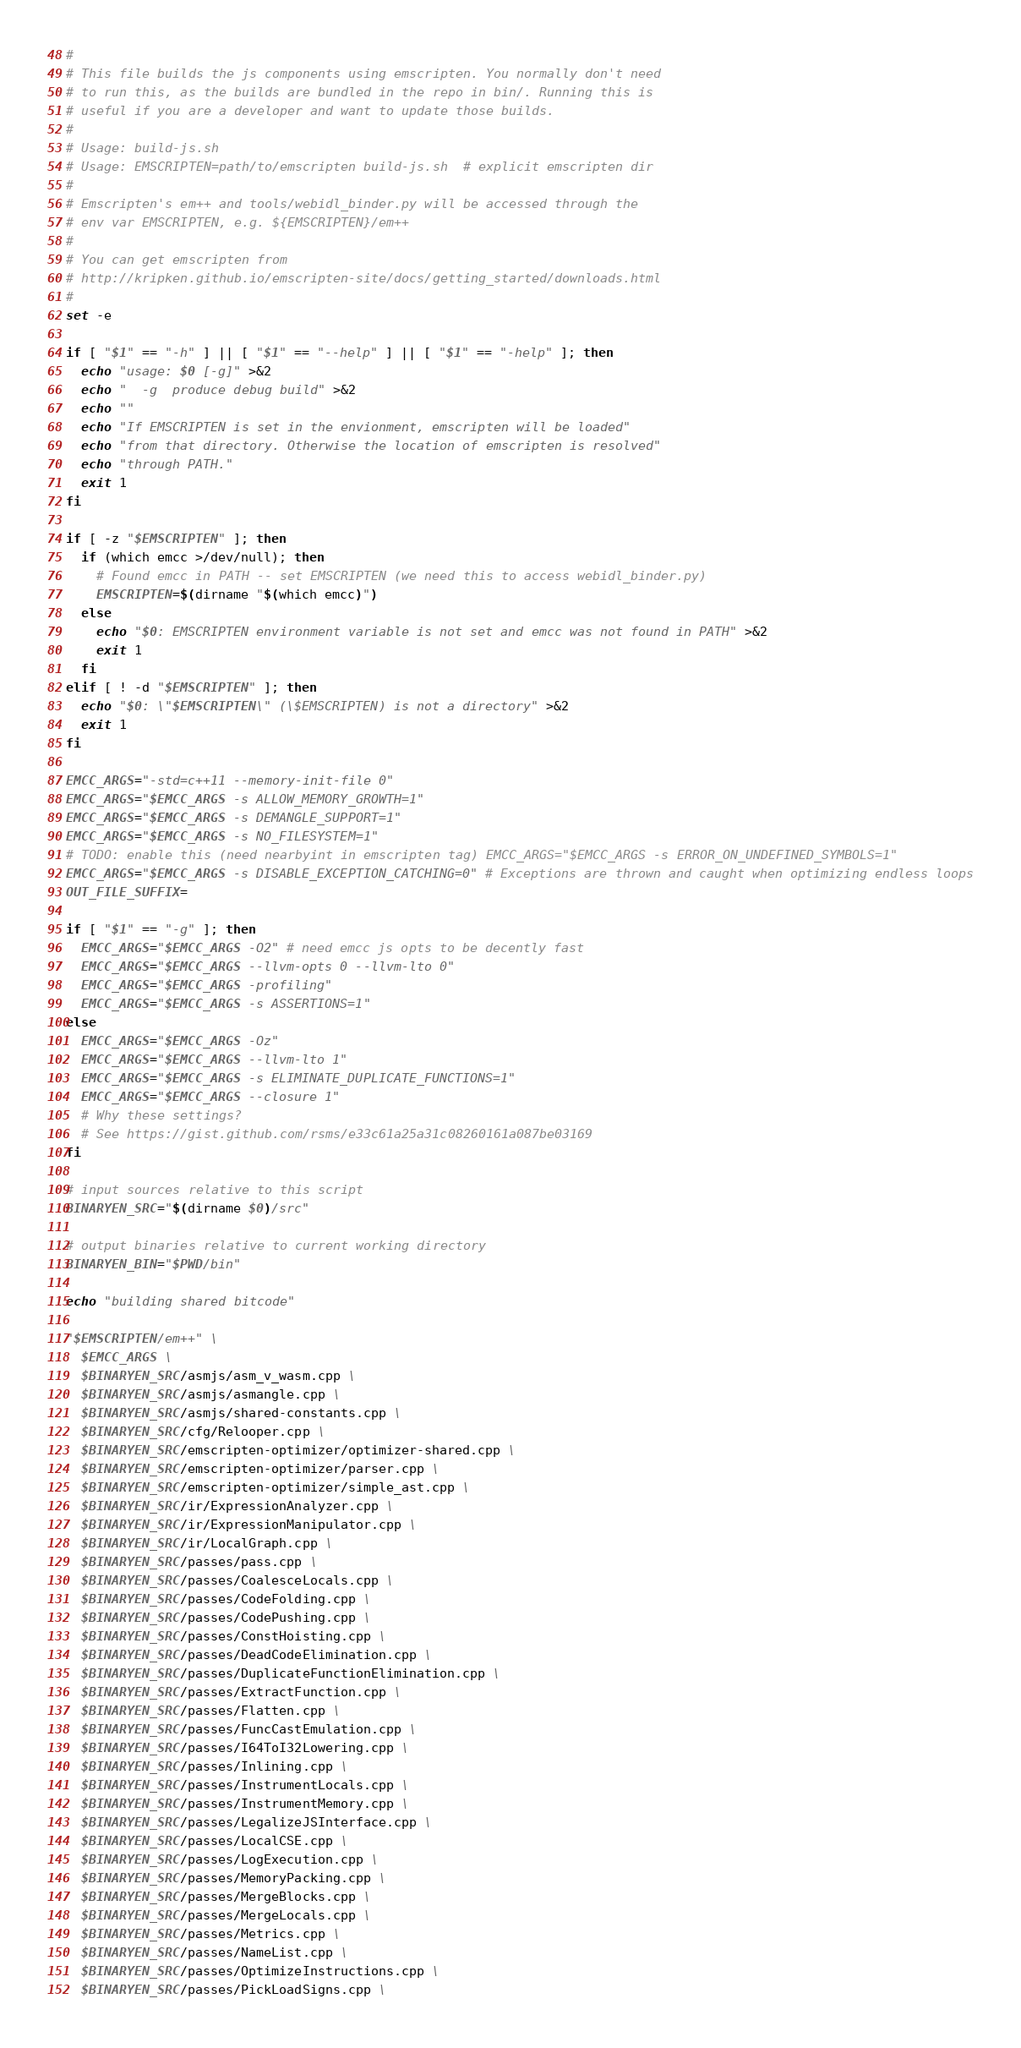<code> <loc_0><loc_0><loc_500><loc_500><_Bash_>#
# This file builds the js components using emscripten. You normally don't need
# to run this, as the builds are bundled in the repo in bin/. Running this is
# useful if you are a developer and want to update those builds.
#
# Usage: build-js.sh
# Usage: EMSCRIPTEN=path/to/emscripten build-js.sh  # explicit emscripten dir
#
# Emscripten's em++ and tools/webidl_binder.py will be accessed through the
# env var EMSCRIPTEN, e.g. ${EMSCRIPTEN}/em++
#
# You can get emscripten from
# http://kripken.github.io/emscripten-site/docs/getting_started/downloads.html
#
set -e

if [ "$1" == "-h" ] || [ "$1" == "--help" ] || [ "$1" == "-help" ]; then
  echo "usage: $0 [-g]" >&2
  echo "  -g  produce debug build" >&2
  echo ""
  echo "If EMSCRIPTEN is set in the envionment, emscripten will be loaded"
  echo "from that directory. Otherwise the location of emscripten is resolved"
  echo "through PATH."
  exit 1
fi

if [ -z "$EMSCRIPTEN" ]; then
  if (which emcc >/dev/null); then
    # Found emcc in PATH -- set EMSCRIPTEN (we need this to access webidl_binder.py)
    EMSCRIPTEN=$(dirname "$(which emcc)")
  else
    echo "$0: EMSCRIPTEN environment variable is not set and emcc was not found in PATH" >&2
    exit 1
  fi
elif [ ! -d "$EMSCRIPTEN" ]; then
  echo "$0: \"$EMSCRIPTEN\" (\$EMSCRIPTEN) is not a directory" >&2
  exit 1
fi

EMCC_ARGS="-std=c++11 --memory-init-file 0"
EMCC_ARGS="$EMCC_ARGS -s ALLOW_MEMORY_GROWTH=1"
EMCC_ARGS="$EMCC_ARGS -s DEMANGLE_SUPPORT=1"
EMCC_ARGS="$EMCC_ARGS -s NO_FILESYSTEM=1"
# TODO: enable this (need nearbyint in emscripten tag) EMCC_ARGS="$EMCC_ARGS -s ERROR_ON_UNDEFINED_SYMBOLS=1"
EMCC_ARGS="$EMCC_ARGS -s DISABLE_EXCEPTION_CATCHING=0" # Exceptions are thrown and caught when optimizing endless loops
OUT_FILE_SUFFIX=

if [ "$1" == "-g" ]; then
  EMCC_ARGS="$EMCC_ARGS -O2" # need emcc js opts to be decently fast
  EMCC_ARGS="$EMCC_ARGS --llvm-opts 0 --llvm-lto 0"
  EMCC_ARGS="$EMCC_ARGS -profiling"
  EMCC_ARGS="$EMCC_ARGS -s ASSERTIONS=1"
else
  EMCC_ARGS="$EMCC_ARGS -Oz"
  EMCC_ARGS="$EMCC_ARGS --llvm-lto 1"
  EMCC_ARGS="$EMCC_ARGS -s ELIMINATE_DUPLICATE_FUNCTIONS=1"
  EMCC_ARGS="$EMCC_ARGS --closure 1"
  # Why these settings?
  # See https://gist.github.com/rsms/e33c61a25a31c08260161a087be03169
fi

# input sources relative to this script
BINARYEN_SRC="$(dirname $0)/src"

# output binaries relative to current working directory
BINARYEN_BIN="$PWD/bin"

echo "building shared bitcode"

"$EMSCRIPTEN/em++" \
  $EMCC_ARGS \
  $BINARYEN_SRC/asmjs/asm_v_wasm.cpp \
  $BINARYEN_SRC/asmjs/asmangle.cpp \
  $BINARYEN_SRC/asmjs/shared-constants.cpp \
  $BINARYEN_SRC/cfg/Relooper.cpp \
  $BINARYEN_SRC/emscripten-optimizer/optimizer-shared.cpp \
  $BINARYEN_SRC/emscripten-optimizer/parser.cpp \
  $BINARYEN_SRC/emscripten-optimizer/simple_ast.cpp \
  $BINARYEN_SRC/ir/ExpressionAnalyzer.cpp \
  $BINARYEN_SRC/ir/ExpressionManipulator.cpp \
  $BINARYEN_SRC/ir/LocalGraph.cpp \
  $BINARYEN_SRC/passes/pass.cpp \
  $BINARYEN_SRC/passes/CoalesceLocals.cpp \
  $BINARYEN_SRC/passes/CodeFolding.cpp \
  $BINARYEN_SRC/passes/CodePushing.cpp \
  $BINARYEN_SRC/passes/ConstHoisting.cpp \
  $BINARYEN_SRC/passes/DeadCodeElimination.cpp \
  $BINARYEN_SRC/passes/DuplicateFunctionElimination.cpp \
  $BINARYEN_SRC/passes/ExtractFunction.cpp \
  $BINARYEN_SRC/passes/Flatten.cpp \
  $BINARYEN_SRC/passes/FuncCastEmulation.cpp \
  $BINARYEN_SRC/passes/I64ToI32Lowering.cpp \
  $BINARYEN_SRC/passes/Inlining.cpp \
  $BINARYEN_SRC/passes/InstrumentLocals.cpp \
  $BINARYEN_SRC/passes/InstrumentMemory.cpp \
  $BINARYEN_SRC/passes/LegalizeJSInterface.cpp \
  $BINARYEN_SRC/passes/LocalCSE.cpp \
  $BINARYEN_SRC/passes/LogExecution.cpp \
  $BINARYEN_SRC/passes/MemoryPacking.cpp \
  $BINARYEN_SRC/passes/MergeBlocks.cpp \
  $BINARYEN_SRC/passes/MergeLocals.cpp \
  $BINARYEN_SRC/passes/Metrics.cpp \
  $BINARYEN_SRC/passes/NameList.cpp \
  $BINARYEN_SRC/passes/OptimizeInstructions.cpp \
  $BINARYEN_SRC/passes/PickLoadSigns.cpp \</code> 